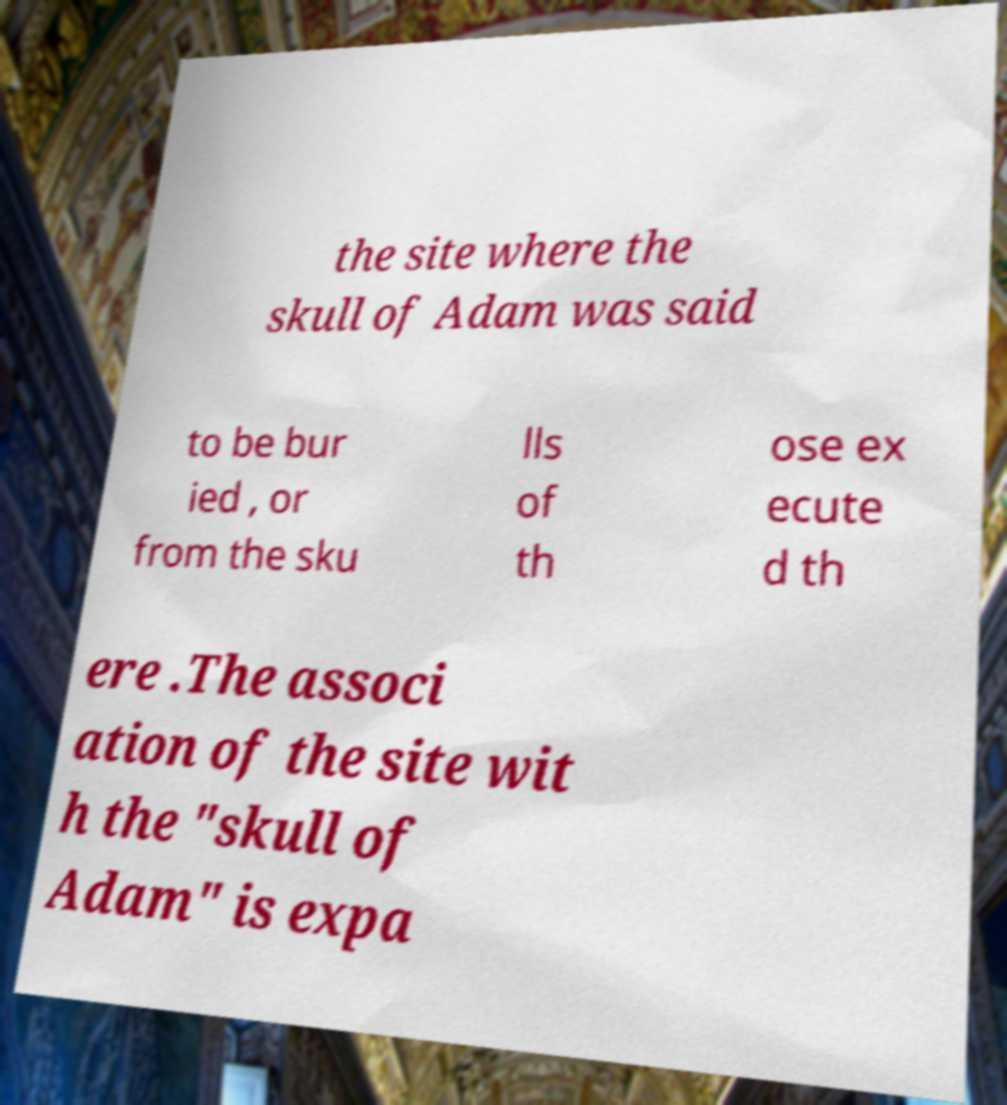For documentation purposes, I need the text within this image transcribed. Could you provide that? the site where the skull of Adam was said to be bur ied , or from the sku lls of th ose ex ecute d th ere .The associ ation of the site wit h the "skull of Adam" is expa 